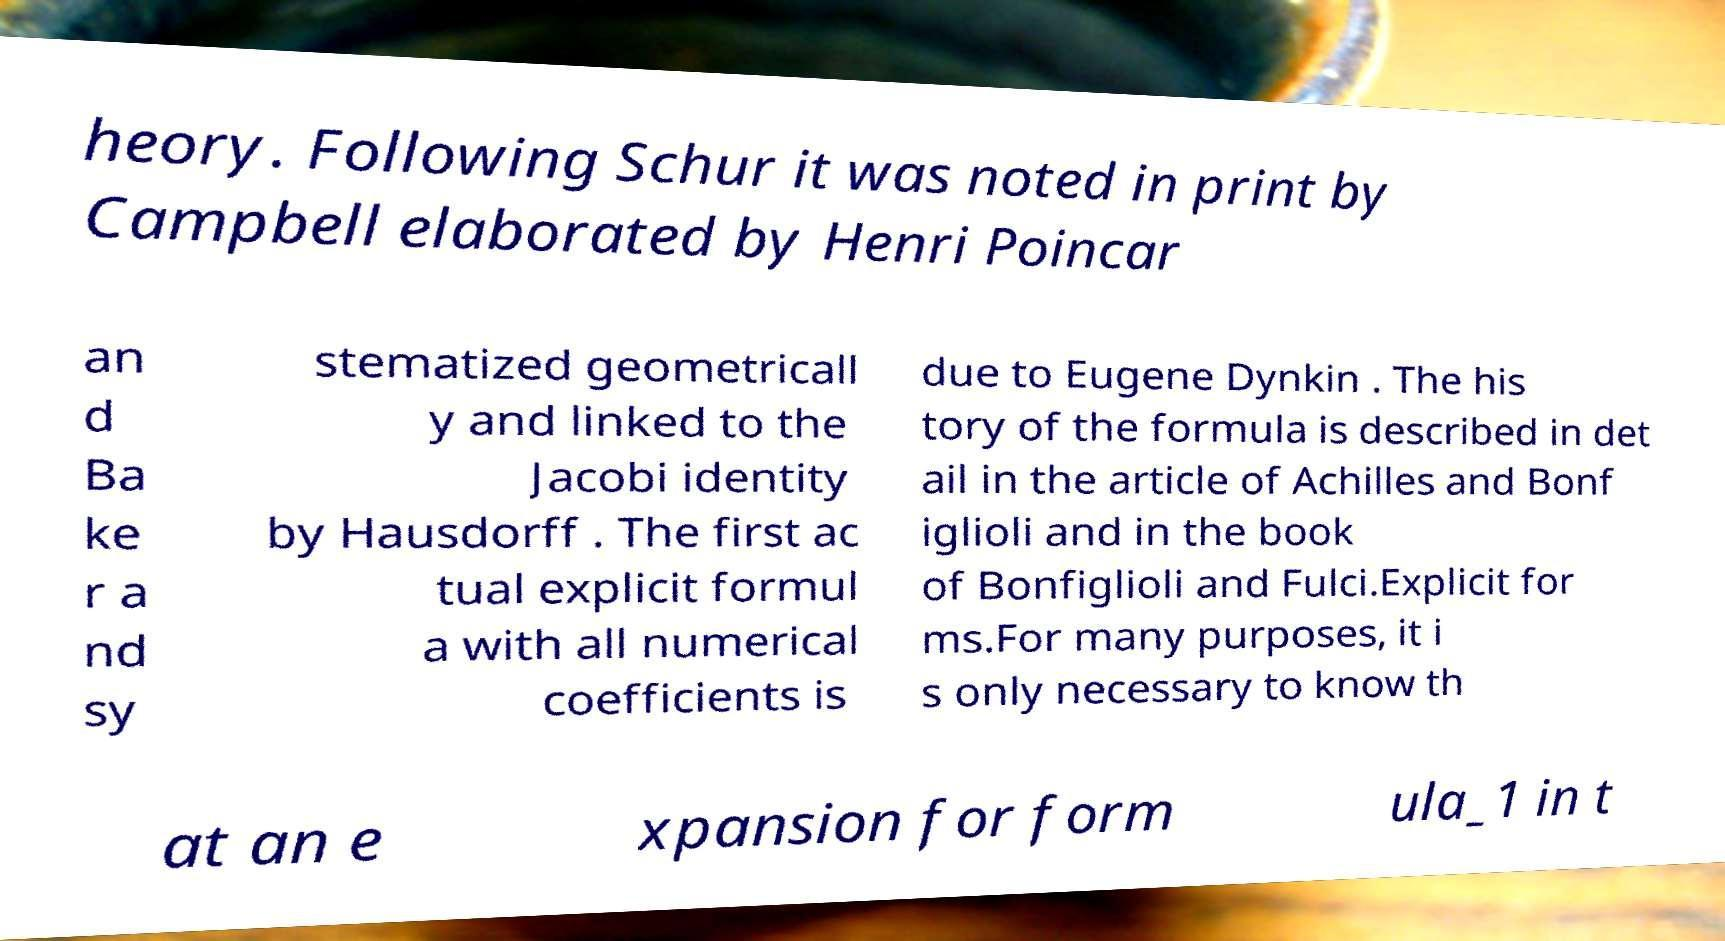Could you assist in decoding the text presented in this image and type it out clearly? heory. Following Schur it was noted in print by Campbell elaborated by Henri Poincar an d Ba ke r a nd sy stematized geometricall y and linked to the Jacobi identity by Hausdorff . The first ac tual explicit formul a with all numerical coefficients is due to Eugene Dynkin . The his tory of the formula is described in det ail in the article of Achilles and Bonf iglioli and in the book of Bonfiglioli and Fulci.Explicit for ms.For many purposes, it i s only necessary to know th at an e xpansion for form ula_1 in t 